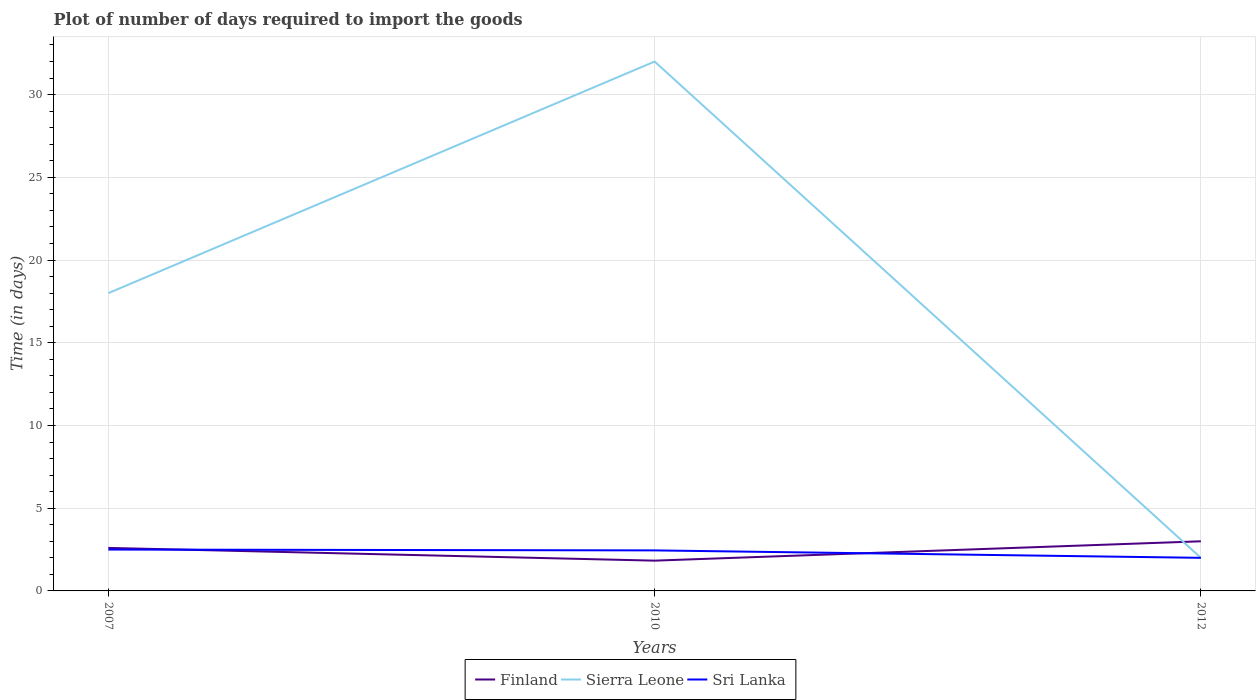How many different coloured lines are there?
Give a very brief answer. 3. Is the number of lines equal to the number of legend labels?
Your answer should be very brief. Yes. Across all years, what is the maximum time required to import goods in Finland?
Give a very brief answer. 1.83. In which year was the time required to import goods in Sierra Leone maximum?
Your answer should be compact. 2012. What is the total time required to import goods in Sri Lanka in the graph?
Provide a succinct answer. 0.05. What is the difference between the highest and the second highest time required to import goods in Sierra Leone?
Provide a succinct answer. 30. What is the difference between two consecutive major ticks on the Y-axis?
Offer a terse response. 5. Does the graph contain grids?
Offer a very short reply. Yes. Where does the legend appear in the graph?
Your answer should be compact. Bottom center. How many legend labels are there?
Your answer should be compact. 3. How are the legend labels stacked?
Offer a terse response. Horizontal. What is the title of the graph?
Your answer should be compact. Plot of number of days required to import the goods. What is the label or title of the X-axis?
Ensure brevity in your answer.  Years. What is the label or title of the Y-axis?
Your answer should be compact. Time (in days). What is the Time (in days) of Finland in 2007?
Keep it short and to the point. 2.6. What is the Time (in days) in Sri Lanka in 2007?
Your answer should be very brief. 2.5. What is the Time (in days) in Finland in 2010?
Your answer should be compact. 1.83. What is the Time (in days) of Sri Lanka in 2010?
Ensure brevity in your answer.  2.45. What is the Time (in days) of Finland in 2012?
Give a very brief answer. 3. What is the Time (in days) of Sierra Leone in 2012?
Your response must be concise. 2. What is the Time (in days) of Sri Lanka in 2012?
Keep it short and to the point. 2. Across all years, what is the maximum Time (in days) of Finland?
Offer a terse response. 3. Across all years, what is the maximum Time (in days) in Sierra Leone?
Your answer should be compact. 32. Across all years, what is the minimum Time (in days) in Finland?
Make the answer very short. 1.83. What is the total Time (in days) of Finland in the graph?
Offer a terse response. 7.43. What is the total Time (in days) of Sierra Leone in the graph?
Make the answer very short. 52. What is the total Time (in days) of Sri Lanka in the graph?
Your answer should be very brief. 6.95. What is the difference between the Time (in days) in Finland in 2007 and that in 2010?
Ensure brevity in your answer.  0.77. What is the difference between the Time (in days) of Finland in 2010 and that in 2012?
Ensure brevity in your answer.  -1.17. What is the difference between the Time (in days) in Sri Lanka in 2010 and that in 2012?
Make the answer very short. 0.45. What is the difference between the Time (in days) of Finland in 2007 and the Time (in days) of Sierra Leone in 2010?
Give a very brief answer. -29.4. What is the difference between the Time (in days) of Finland in 2007 and the Time (in days) of Sri Lanka in 2010?
Your answer should be compact. 0.15. What is the difference between the Time (in days) of Sierra Leone in 2007 and the Time (in days) of Sri Lanka in 2010?
Offer a very short reply. 15.55. What is the difference between the Time (in days) in Finland in 2007 and the Time (in days) in Sierra Leone in 2012?
Your answer should be very brief. 0.6. What is the difference between the Time (in days) in Finland in 2007 and the Time (in days) in Sri Lanka in 2012?
Provide a succinct answer. 0.6. What is the difference between the Time (in days) of Sierra Leone in 2007 and the Time (in days) of Sri Lanka in 2012?
Your answer should be very brief. 16. What is the difference between the Time (in days) in Finland in 2010 and the Time (in days) in Sierra Leone in 2012?
Ensure brevity in your answer.  -0.17. What is the difference between the Time (in days) in Finland in 2010 and the Time (in days) in Sri Lanka in 2012?
Ensure brevity in your answer.  -0.17. What is the difference between the Time (in days) in Sierra Leone in 2010 and the Time (in days) in Sri Lanka in 2012?
Offer a terse response. 30. What is the average Time (in days) in Finland per year?
Give a very brief answer. 2.48. What is the average Time (in days) in Sierra Leone per year?
Your response must be concise. 17.33. What is the average Time (in days) in Sri Lanka per year?
Your answer should be compact. 2.32. In the year 2007, what is the difference between the Time (in days) of Finland and Time (in days) of Sierra Leone?
Offer a very short reply. -15.4. In the year 2010, what is the difference between the Time (in days) in Finland and Time (in days) in Sierra Leone?
Provide a succinct answer. -30.17. In the year 2010, what is the difference between the Time (in days) of Finland and Time (in days) of Sri Lanka?
Your answer should be compact. -0.62. In the year 2010, what is the difference between the Time (in days) of Sierra Leone and Time (in days) of Sri Lanka?
Offer a very short reply. 29.55. In the year 2012, what is the difference between the Time (in days) in Finland and Time (in days) in Sri Lanka?
Offer a terse response. 1. In the year 2012, what is the difference between the Time (in days) of Sierra Leone and Time (in days) of Sri Lanka?
Keep it short and to the point. 0. What is the ratio of the Time (in days) in Finland in 2007 to that in 2010?
Ensure brevity in your answer.  1.42. What is the ratio of the Time (in days) of Sierra Leone in 2007 to that in 2010?
Your answer should be very brief. 0.56. What is the ratio of the Time (in days) in Sri Lanka in 2007 to that in 2010?
Ensure brevity in your answer.  1.02. What is the ratio of the Time (in days) of Finland in 2007 to that in 2012?
Ensure brevity in your answer.  0.87. What is the ratio of the Time (in days) of Sri Lanka in 2007 to that in 2012?
Your response must be concise. 1.25. What is the ratio of the Time (in days) of Finland in 2010 to that in 2012?
Provide a short and direct response. 0.61. What is the ratio of the Time (in days) in Sri Lanka in 2010 to that in 2012?
Keep it short and to the point. 1.23. What is the difference between the highest and the second highest Time (in days) in Finland?
Make the answer very short. 0.4. What is the difference between the highest and the second highest Time (in days) in Sri Lanka?
Provide a succinct answer. 0.05. What is the difference between the highest and the lowest Time (in days) of Finland?
Offer a very short reply. 1.17. 